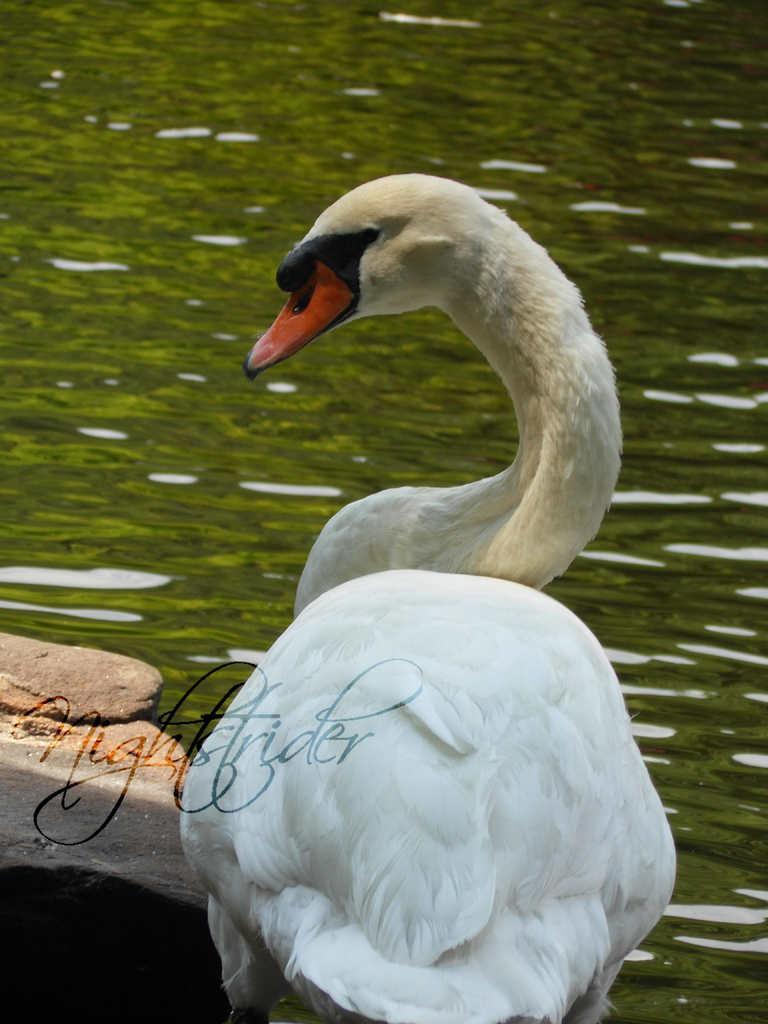Describe this image in one or two sentences. In this image I can see the bird which is in white, black and red color. It is on the rock. To the side I can see the water. 